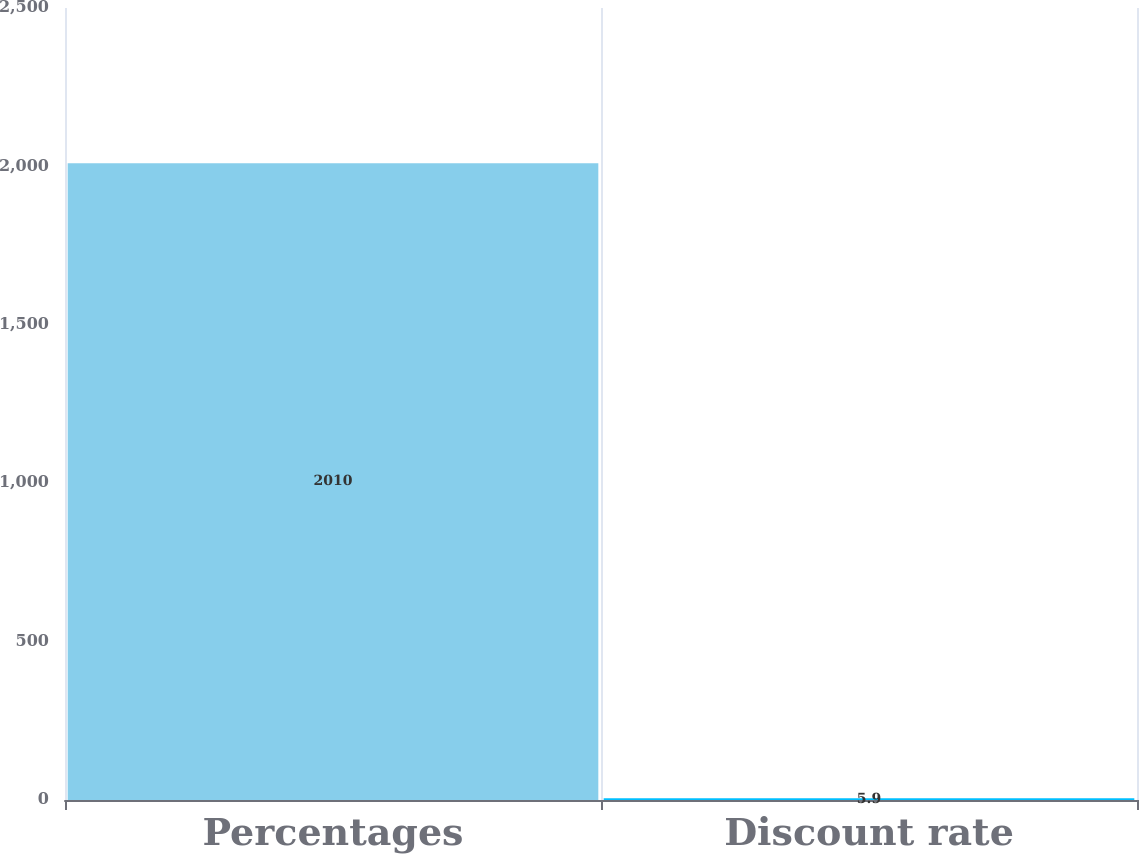Convert chart. <chart><loc_0><loc_0><loc_500><loc_500><bar_chart><fcel>Percentages<fcel>Discount rate<nl><fcel>2010<fcel>5.9<nl></chart> 